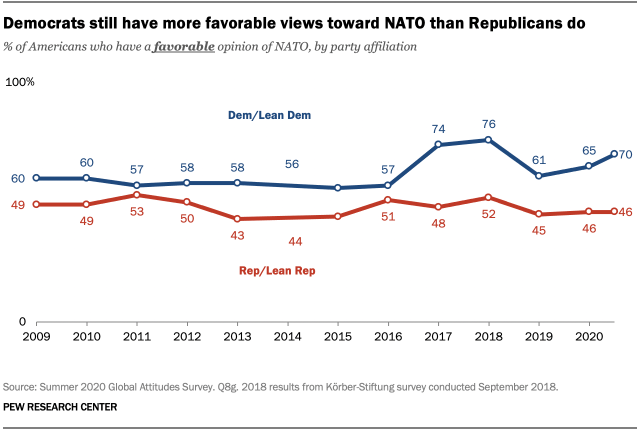Highlight a few significant elements in this photo. The peak of blue lines is expected to be reached in 2018. The blue line represents the Democratic Party or leaning Democratic. 